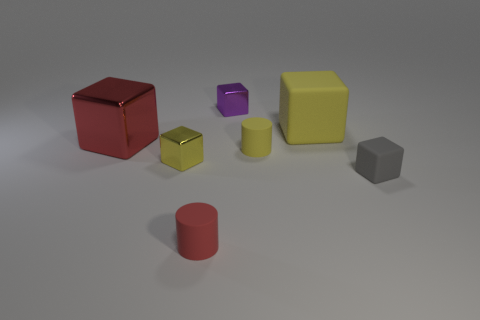There is a tiny block that is both on the left side of the yellow cylinder and in front of the small purple thing; what material is it? The tiny block located to the left of the yellow cylinder and in front of the small purple object appears to have a metallic sheen, suggesting that it is made of metal. Given the image quality and context, this would be an educated guess based on the visual cues. 